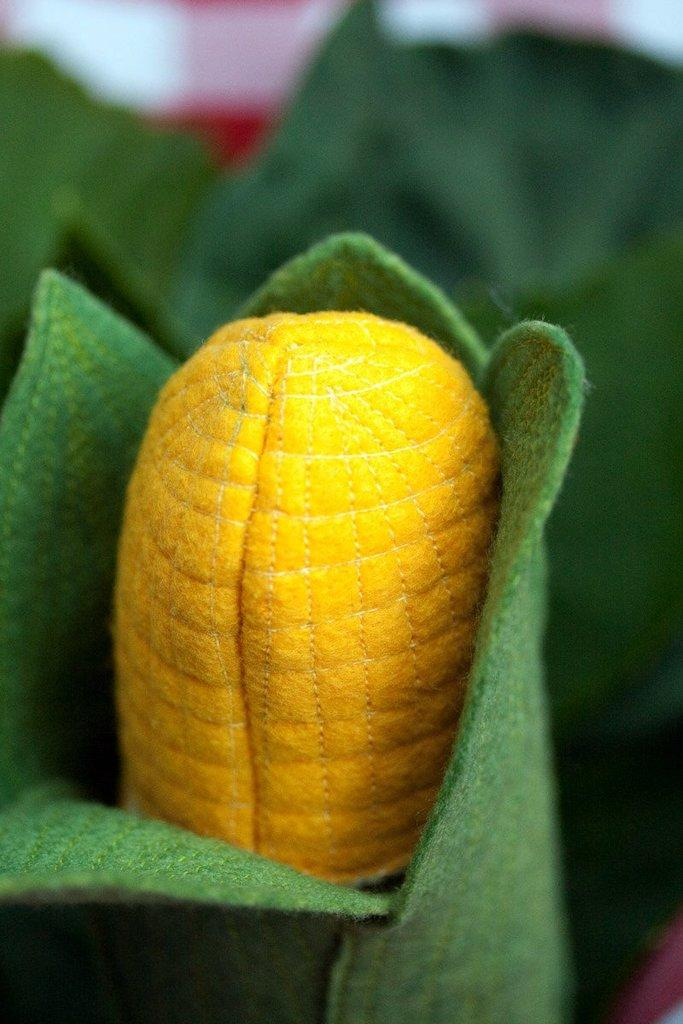What is the main subject of the image? There is a craft in the image. What type of plant can be seen in the image? Maize is visible in the image. What other natural elements are present in the image? Leaves are present in the image. How would you describe the background of the image? The background has a blurred view. What committee is responsible for the loss of the actor in the image? There is no committee, loss, or actor mentioned or depicted in the image. 